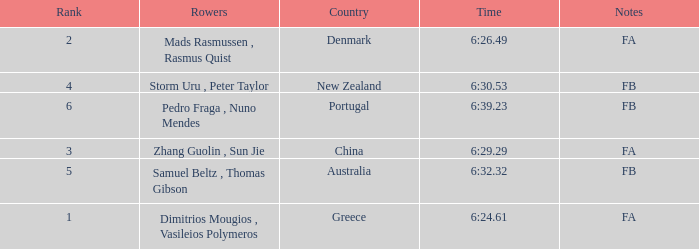What country has a rank smaller than 6, a time of 6:32.32 and notes of FB? Australia. 